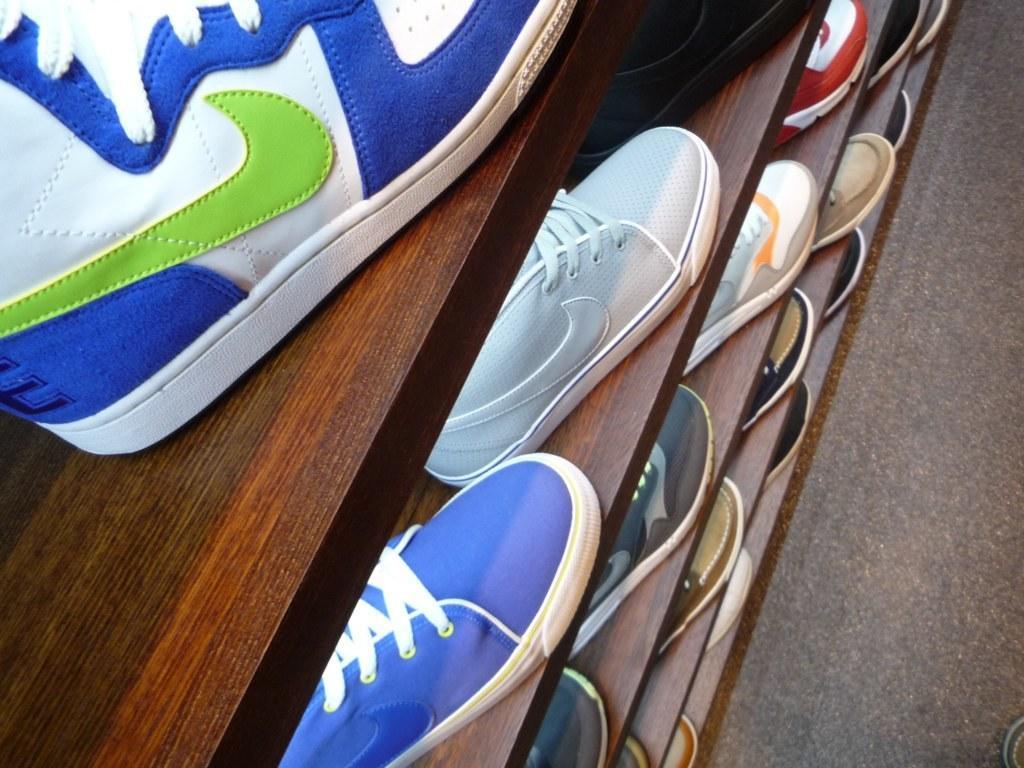In one or two sentences, can you explain what this image depicts? In this image we can see shoes on the racks and on the right side at the bottom corner we can see an object on the floor. 